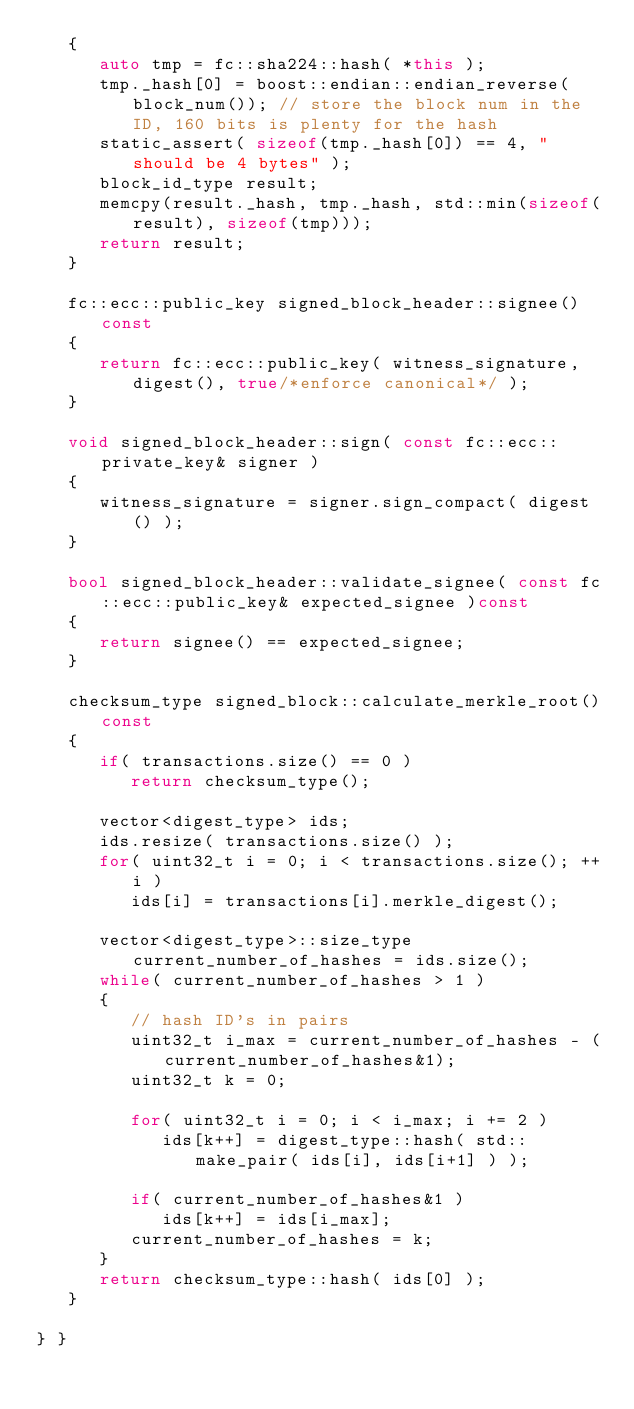Convert code to text. <code><loc_0><loc_0><loc_500><loc_500><_C++_>   {
      auto tmp = fc::sha224::hash( *this );
      tmp._hash[0] = boost::endian::endian_reverse(block_num()); // store the block num in the ID, 160 bits is plenty for the hash
      static_assert( sizeof(tmp._hash[0]) == 4, "should be 4 bytes" );
      block_id_type result;
      memcpy(result._hash, tmp._hash, std::min(sizeof(result), sizeof(tmp)));
      return result;
   }

   fc::ecc::public_key signed_block_header::signee()const
   {
      return fc::ecc::public_key( witness_signature, digest(), true/*enforce canonical*/ );
   }

   void signed_block_header::sign( const fc::ecc::private_key& signer )
   {
      witness_signature = signer.sign_compact( digest() );
   }

   bool signed_block_header::validate_signee( const fc::ecc::public_key& expected_signee )const
   {
      return signee() == expected_signee;
   }

   checksum_type signed_block::calculate_merkle_root()const
   {
      if( transactions.size() == 0 ) 
         return checksum_type();

      vector<digest_type> ids;
      ids.resize( transactions.size() );
      for( uint32_t i = 0; i < transactions.size(); ++i )
         ids[i] = transactions[i].merkle_digest();

      vector<digest_type>::size_type current_number_of_hashes = ids.size();
      while( current_number_of_hashes > 1 )
      {
         // hash ID's in pairs
         uint32_t i_max = current_number_of_hashes - (current_number_of_hashes&1);
         uint32_t k = 0;

         for( uint32_t i = 0; i < i_max; i += 2 )
            ids[k++] = digest_type::hash( std::make_pair( ids[i], ids[i+1] ) );

         if( current_number_of_hashes&1 )
            ids[k++] = ids[i_max];
         current_number_of_hashes = k;
      }
      return checksum_type::hash( ids[0] );
   }

} }
</code> 